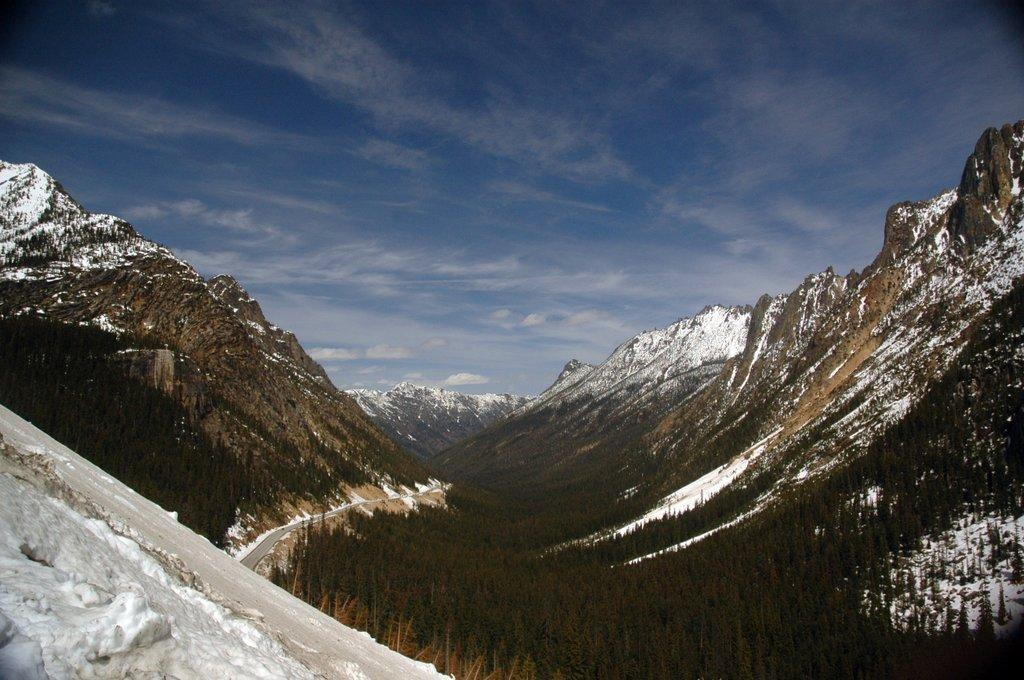What type of geographical feature is present in the image? There are mountains in the image. What is the condition of the mountains in the image? The mountains have snow on them and trees growing on them. Can you describe the road visible in the image? There is a road visible in the image, but its specific characteristics are not mentioned in the facts. What is visible in the sky in the image? There are clouds in the sky in the image. Where is the volleyball court located in the image? There is no volleyball court present in the image. What is your opinion on the cellar in the image? There is no mention of a cellar in the image or the facts provided. 